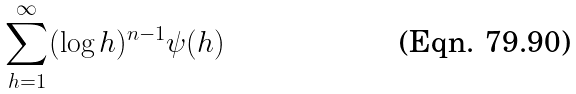Convert formula to latex. <formula><loc_0><loc_0><loc_500><loc_500>\sum _ { h = 1 } ^ { \infty } ( \log h ) ^ { n - 1 } { \psi ( h ) }</formula> 